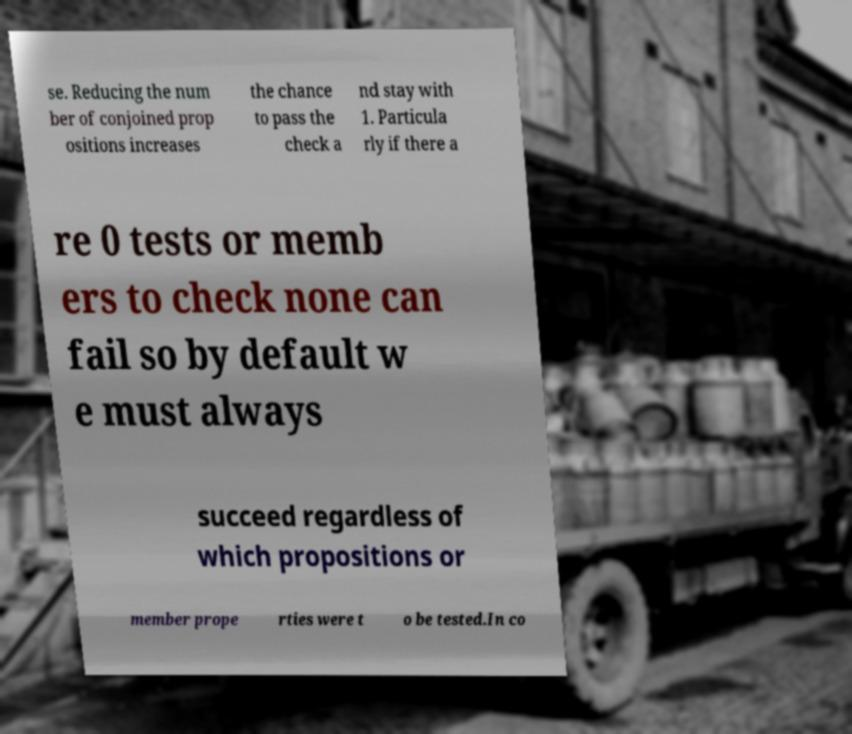For documentation purposes, I need the text within this image transcribed. Could you provide that? se. Reducing the num ber of conjoined prop ositions increases the chance to pass the check a nd stay with 1. Particula rly if there a re 0 tests or memb ers to check none can fail so by default w e must always succeed regardless of which propositions or member prope rties were t o be tested.In co 